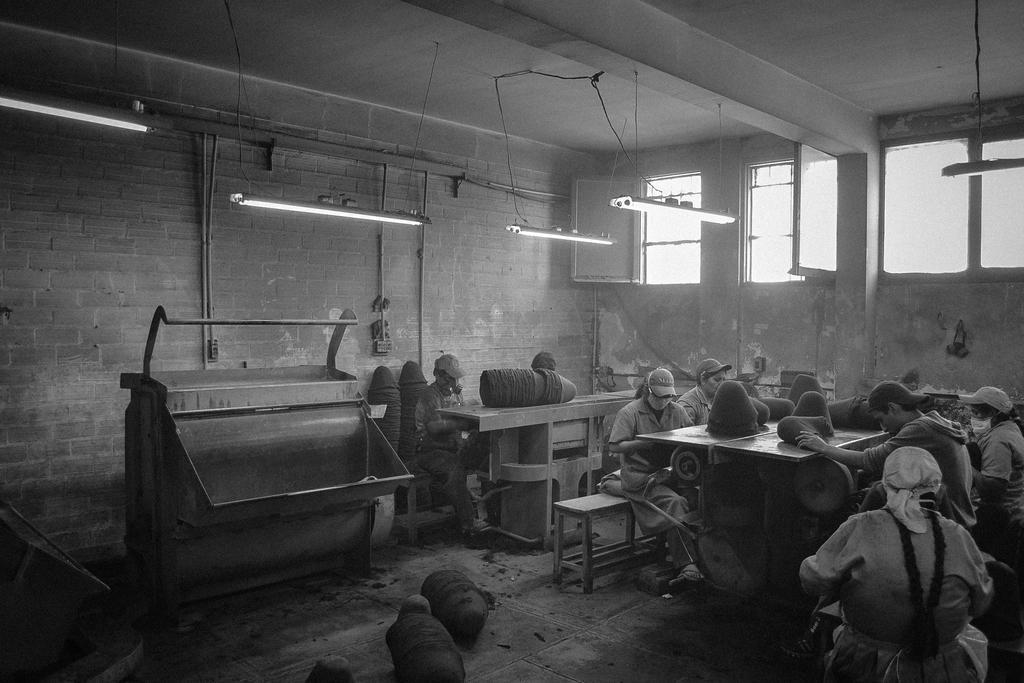Could you give a brief overview of what you see in this image? This is a black and white picture. There are many people sitting wearing caps. There are tables and benches. There are tube lights hanging on ceilings. There are windows and walls. 